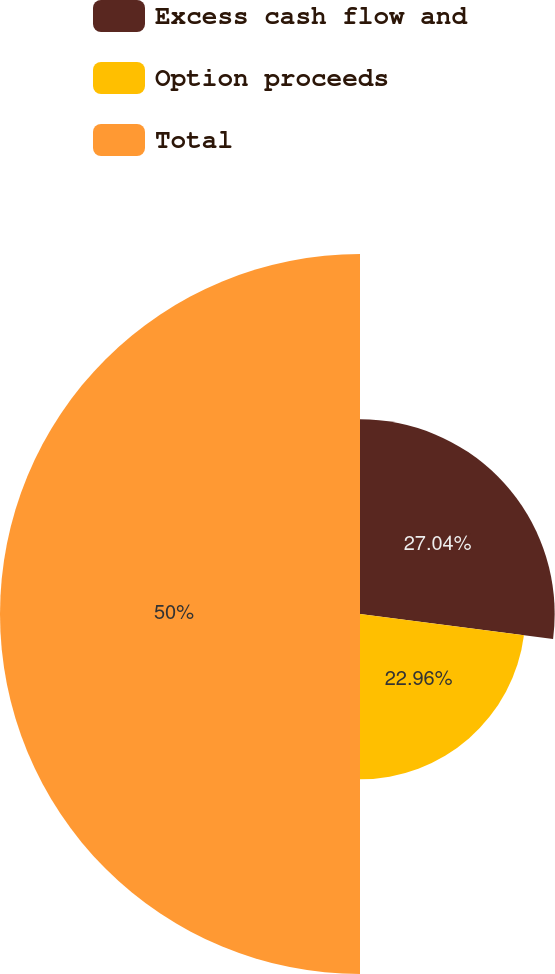Convert chart to OTSL. <chart><loc_0><loc_0><loc_500><loc_500><pie_chart><fcel>Excess cash flow and<fcel>Option proceeds<fcel>Total<nl><fcel>27.04%<fcel>22.96%<fcel>50.0%<nl></chart> 